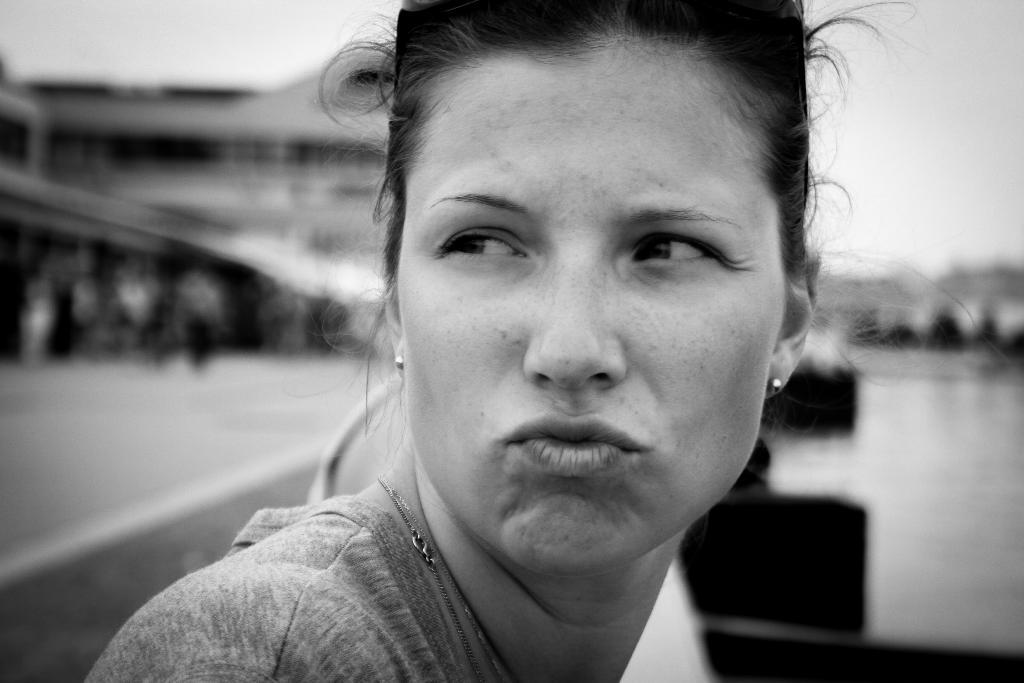Who is the main subject in the picture? There is a woman in the picture. Can you describe the background of the picture? The background of the picture is blurry. What is the color scheme of the photography? The photography is in black and white. How many giants can be seen in the picture? There are no giants present in the picture; it features a woman in a black and white photograph with a blurry background. 